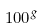Convert formula to latex. <formula><loc_0><loc_0><loc_500><loc_500>1 0 0 ^ { g }</formula> 